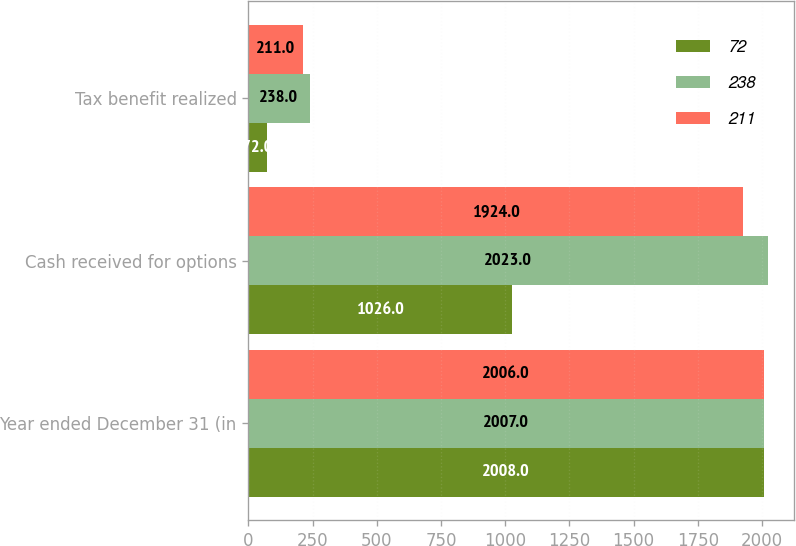Convert chart to OTSL. <chart><loc_0><loc_0><loc_500><loc_500><stacked_bar_chart><ecel><fcel>Year ended December 31 (in<fcel>Cash received for options<fcel>Tax benefit realized<nl><fcel>72<fcel>2008<fcel>1026<fcel>72<nl><fcel>238<fcel>2007<fcel>2023<fcel>238<nl><fcel>211<fcel>2006<fcel>1924<fcel>211<nl></chart> 